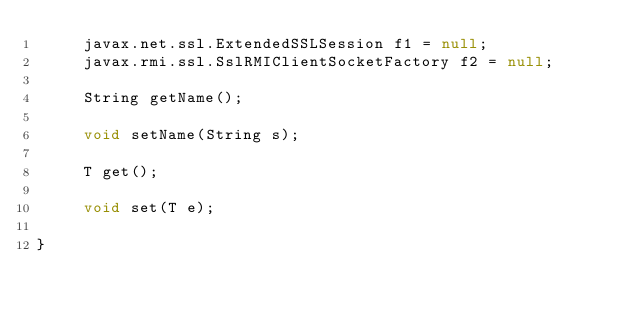<code> <loc_0><loc_0><loc_500><loc_500><_Java_>	 javax.net.ssl.ExtendedSSLSession f1 = null;
	 javax.rmi.ssl.SslRMIClientSocketFactory f2 = null;

	 String getName();

	 void setName(String s);

	 T get();

	 void set(T e);

}
</code> 